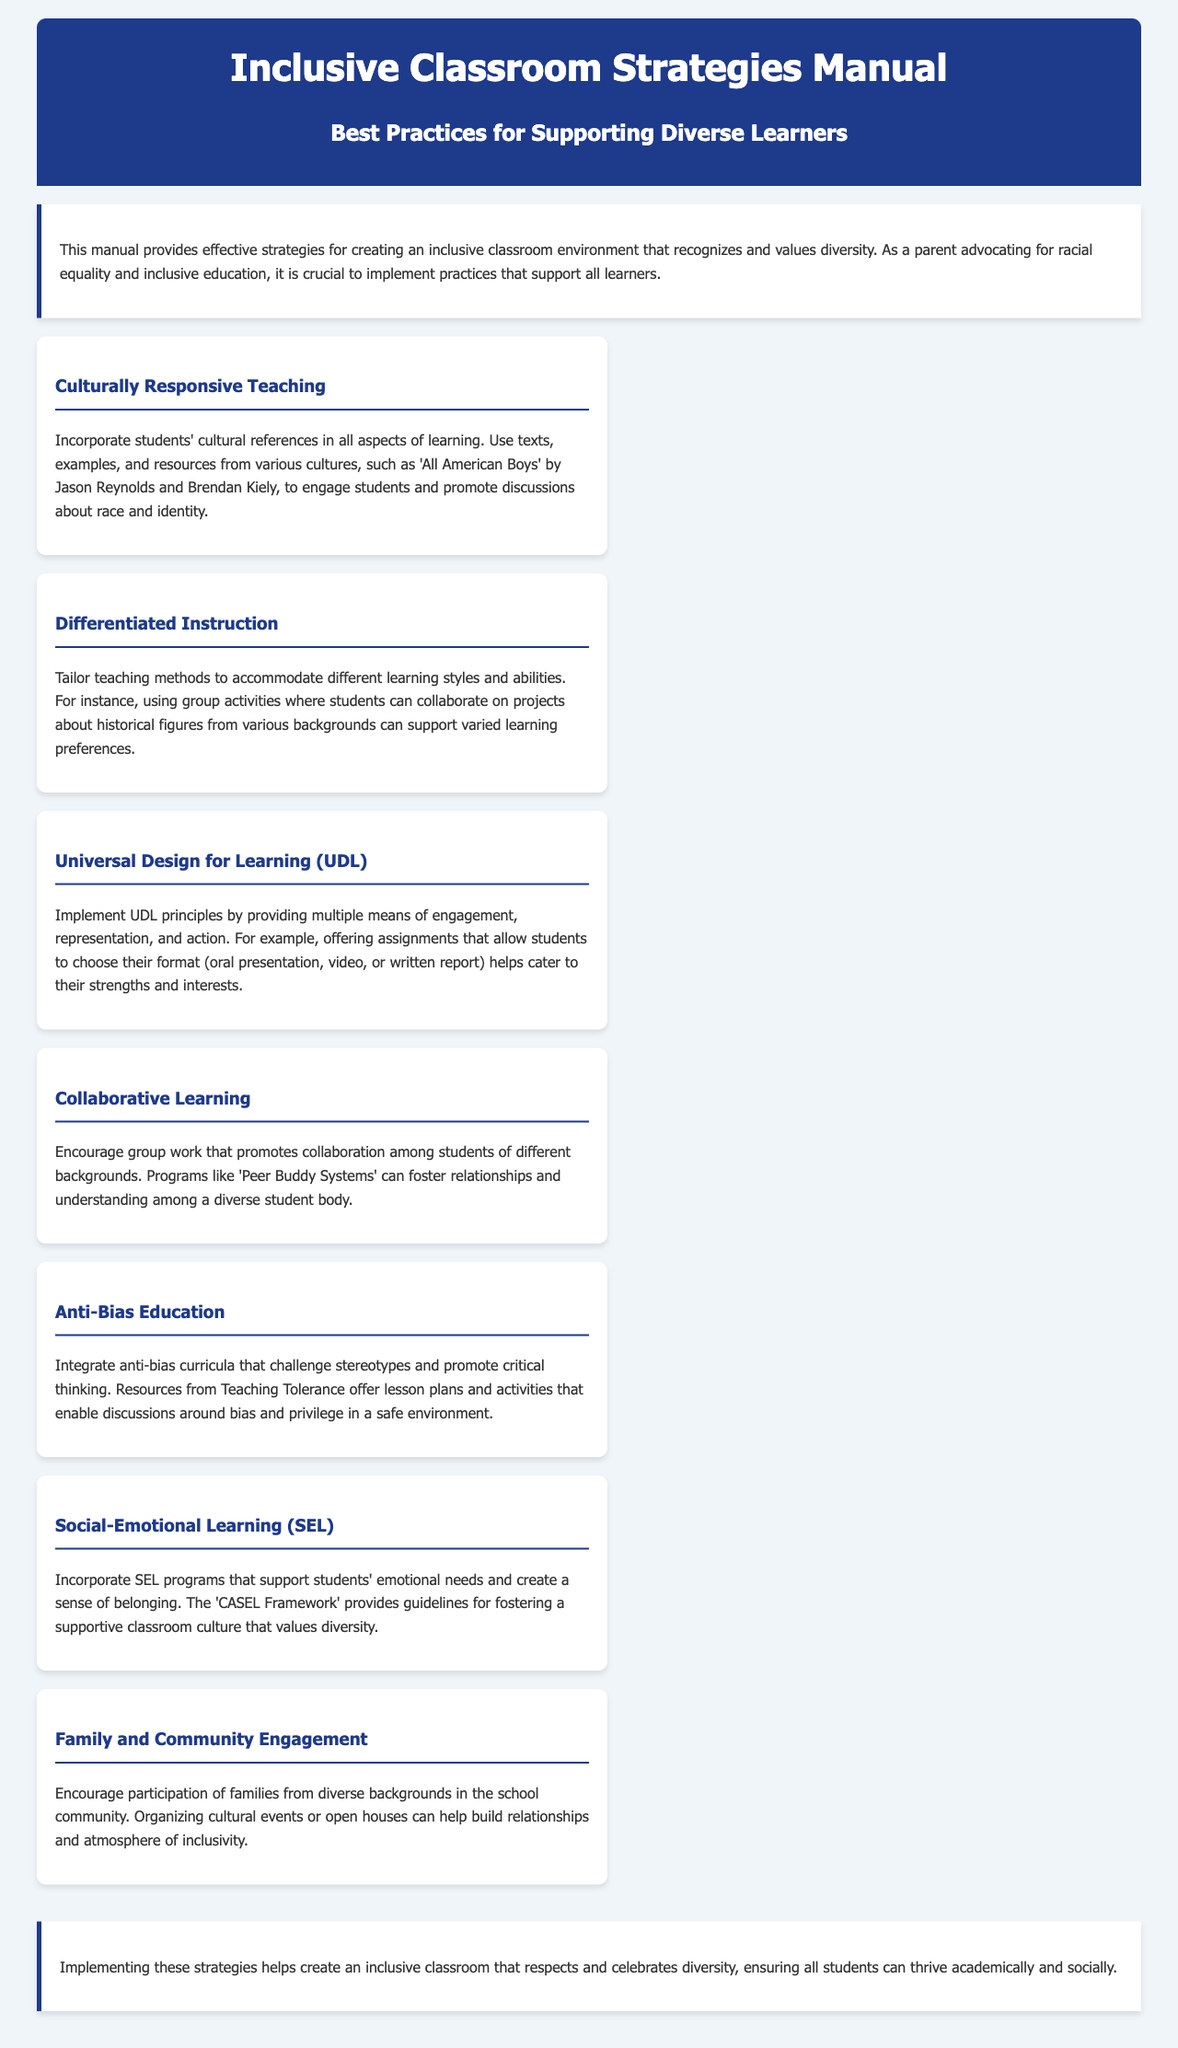What is the title of the manual? The title of the manual is presented prominently in the header section.
Answer: Inclusive Classroom Strategies Manual What are the best practices mentioned in the manual? The manual focuses on strategies for supporting diverse learners, which are categorized under best practices.
Answer: Supporting Diverse Learners Name one text referenced for culturally responsive teaching. The document lists specific texts used to promote discussions about race and identity.
Answer: All American Boys What strategy involves tailoring teaching methods? The document outlines various strategies to support diverse learners, including specific methods for instruction.
Answer: Differentiated Instruction What system is mentioned to promote collaboration among students? The manual describes a program designed to encourage relationships among diverse students.
Answer: Peer Buddy Systems What does UDL stand for? The manual uses a specific abbreviation related to an educational framework for all learners.
Answer: Universal Design for Learning How many strategies are outlined in the manual? The document clearly defines a set number of strategies for inclusive education.
Answer: Seven What framework supports social-emotional learning? The manual suggests a recognized framework for fostering supportive classroom conditions.
Answer: CASEL Framework 